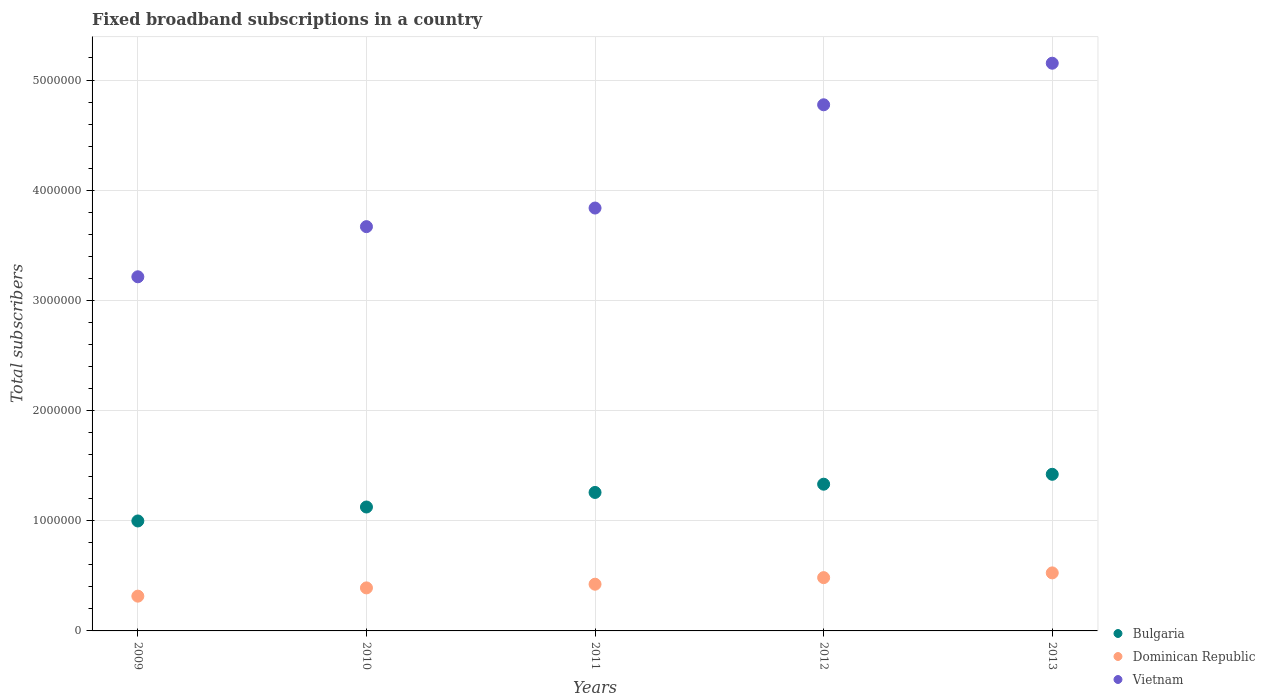How many different coloured dotlines are there?
Your answer should be very brief. 3. Is the number of dotlines equal to the number of legend labels?
Your answer should be very brief. Yes. What is the number of broadband subscriptions in Dominican Republic in 2010?
Offer a terse response. 3.91e+05. Across all years, what is the maximum number of broadband subscriptions in Bulgaria?
Your answer should be very brief. 1.42e+06. Across all years, what is the minimum number of broadband subscriptions in Vietnam?
Your answer should be compact. 3.21e+06. What is the total number of broadband subscriptions in Vietnam in the graph?
Provide a succinct answer. 2.06e+07. What is the difference between the number of broadband subscriptions in Bulgaria in 2009 and that in 2010?
Ensure brevity in your answer.  -1.27e+05. What is the difference between the number of broadband subscriptions in Bulgaria in 2011 and the number of broadband subscriptions in Vietnam in 2009?
Give a very brief answer. -1.96e+06. What is the average number of broadband subscriptions in Vietnam per year?
Provide a succinct answer. 4.13e+06. In the year 2010, what is the difference between the number of broadband subscriptions in Dominican Republic and number of broadband subscriptions in Bulgaria?
Offer a terse response. -7.34e+05. What is the ratio of the number of broadband subscriptions in Bulgaria in 2011 to that in 2013?
Offer a terse response. 0.88. Is the number of broadband subscriptions in Dominican Republic in 2010 less than that in 2011?
Give a very brief answer. Yes. Is the difference between the number of broadband subscriptions in Dominican Republic in 2011 and 2012 greater than the difference between the number of broadband subscriptions in Bulgaria in 2011 and 2012?
Provide a short and direct response. Yes. What is the difference between the highest and the second highest number of broadband subscriptions in Bulgaria?
Offer a terse response. 8.98e+04. What is the difference between the highest and the lowest number of broadband subscriptions in Vietnam?
Offer a very short reply. 1.94e+06. Is the sum of the number of broadband subscriptions in Dominican Republic in 2009 and 2012 greater than the maximum number of broadband subscriptions in Vietnam across all years?
Provide a succinct answer. No. Is it the case that in every year, the sum of the number of broadband subscriptions in Dominican Republic and number of broadband subscriptions in Bulgaria  is greater than the number of broadband subscriptions in Vietnam?
Your answer should be very brief. No. Is the number of broadband subscriptions in Vietnam strictly less than the number of broadband subscriptions in Dominican Republic over the years?
Offer a very short reply. No. How many dotlines are there?
Ensure brevity in your answer.  3. How many years are there in the graph?
Keep it short and to the point. 5. Does the graph contain grids?
Provide a succinct answer. Yes. Where does the legend appear in the graph?
Offer a terse response. Bottom right. How many legend labels are there?
Provide a succinct answer. 3. What is the title of the graph?
Provide a succinct answer. Fixed broadband subscriptions in a country. Does "Comoros" appear as one of the legend labels in the graph?
Provide a short and direct response. No. What is the label or title of the Y-axis?
Your response must be concise. Total subscribers. What is the Total subscribers in Bulgaria in 2009?
Your answer should be very brief. 9.98e+05. What is the Total subscribers in Dominican Republic in 2009?
Your answer should be compact. 3.16e+05. What is the Total subscribers of Vietnam in 2009?
Keep it short and to the point. 3.21e+06. What is the Total subscribers of Bulgaria in 2010?
Make the answer very short. 1.12e+06. What is the Total subscribers in Dominican Republic in 2010?
Provide a short and direct response. 3.91e+05. What is the Total subscribers in Vietnam in 2010?
Provide a short and direct response. 3.67e+06. What is the Total subscribers in Bulgaria in 2011?
Make the answer very short. 1.26e+06. What is the Total subscribers of Dominican Republic in 2011?
Your answer should be compact. 4.24e+05. What is the Total subscribers of Vietnam in 2011?
Offer a very short reply. 3.84e+06. What is the Total subscribers in Bulgaria in 2012?
Provide a short and direct response. 1.33e+06. What is the Total subscribers of Dominican Republic in 2012?
Give a very brief answer. 4.84e+05. What is the Total subscribers in Vietnam in 2012?
Give a very brief answer. 4.78e+06. What is the Total subscribers of Bulgaria in 2013?
Provide a succinct answer. 1.42e+06. What is the Total subscribers in Dominican Republic in 2013?
Provide a short and direct response. 5.27e+05. What is the Total subscribers of Vietnam in 2013?
Your answer should be compact. 5.15e+06. Across all years, what is the maximum Total subscribers of Bulgaria?
Ensure brevity in your answer.  1.42e+06. Across all years, what is the maximum Total subscribers of Dominican Republic?
Give a very brief answer. 5.27e+05. Across all years, what is the maximum Total subscribers of Vietnam?
Provide a succinct answer. 5.15e+06. Across all years, what is the minimum Total subscribers in Bulgaria?
Offer a very short reply. 9.98e+05. Across all years, what is the minimum Total subscribers of Dominican Republic?
Your response must be concise. 3.16e+05. Across all years, what is the minimum Total subscribers of Vietnam?
Offer a very short reply. 3.21e+06. What is the total Total subscribers in Bulgaria in the graph?
Offer a terse response. 6.13e+06. What is the total Total subscribers of Dominican Republic in the graph?
Give a very brief answer. 2.14e+06. What is the total Total subscribers of Vietnam in the graph?
Make the answer very short. 2.06e+07. What is the difference between the Total subscribers in Bulgaria in 2009 and that in 2010?
Provide a short and direct response. -1.27e+05. What is the difference between the Total subscribers of Dominican Republic in 2009 and that in 2010?
Your answer should be very brief. -7.49e+04. What is the difference between the Total subscribers of Vietnam in 2009 and that in 2010?
Offer a very short reply. -4.55e+05. What is the difference between the Total subscribers of Bulgaria in 2009 and that in 2011?
Your answer should be compact. -2.59e+05. What is the difference between the Total subscribers of Dominican Republic in 2009 and that in 2011?
Your answer should be very brief. -1.08e+05. What is the difference between the Total subscribers of Vietnam in 2009 and that in 2011?
Offer a terse response. -6.24e+05. What is the difference between the Total subscribers of Bulgaria in 2009 and that in 2012?
Your response must be concise. -3.34e+05. What is the difference between the Total subscribers of Dominican Republic in 2009 and that in 2012?
Keep it short and to the point. -1.68e+05. What is the difference between the Total subscribers in Vietnam in 2009 and that in 2012?
Provide a succinct answer. -1.56e+06. What is the difference between the Total subscribers in Bulgaria in 2009 and that in 2013?
Provide a short and direct response. -4.24e+05. What is the difference between the Total subscribers of Dominican Republic in 2009 and that in 2013?
Your answer should be very brief. -2.11e+05. What is the difference between the Total subscribers of Vietnam in 2009 and that in 2013?
Your response must be concise. -1.94e+06. What is the difference between the Total subscribers of Bulgaria in 2010 and that in 2011?
Keep it short and to the point. -1.32e+05. What is the difference between the Total subscribers of Dominican Republic in 2010 and that in 2011?
Your answer should be compact. -3.34e+04. What is the difference between the Total subscribers of Vietnam in 2010 and that in 2011?
Your answer should be compact. -1.69e+05. What is the difference between the Total subscribers in Bulgaria in 2010 and that in 2012?
Ensure brevity in your answer.  -2.07e+05. What is the difference between the Total subscribers of Dominican Republic in 2010 and that in 2012?
Your response must be concise. -9.31e+04. What is the difference between the Total subscribers in Vietnam in 2010 and that in 2012?
Keep it short and to the point. -1.11e+06. What is the difference between the Total subscribers in Bulgaria in 2010 and that in 2013?
Your answer should be very brief. -2.97e+05. What is the difference between the Total subscribers in Dominican Republic in 2010 and that in 2013?
Give a very brief answer. -1.36e+05. What is the difference between the Total subscribers of Vietnam in 2010 and that in 2013?
Provide a short and direct response. -1.48e+06. What is the difference between the Total subscribers in Bulgaria in 2011 and that in 2012?
Offer a very short reply. -7.50e+04. What is the difference between the Total subscribers of Dominican Republic in 2011 and that in 2012?
Ensure brevity in your answer.  -5.97e+04. What is the difference between the Total subscribers in Vietnam in 2011 and that in 2012?
Make the answer very short. -9.37e+05. What is the difference between the Total subscribers in Bulgaria in 2011 and that in 2013?
Your answer should be very brief. -1.65e+05. What is the difference between the Total subscribers in Dominican Republic in 2011 and that in 2013?
Your answer should be very brief. -1.03e+05. What is the difference between the Total subscribers of Vietnam in 2011 and that in 2013?
Your answer should be very brief. -1.31e+06. What is the difference between the Total subscribers of Bulgaria in 2012 and that in 2013?
Provide a succinct answer. -8.98e+04. What is the difference between the Total subscribers of Dominican Republic in 2012 and that in 2013?
Keep it short and to the point. -4.31e+04. What is the difference between the Total subscribers of Vietnam in 2012 and that in 2013?
Your answer should be very brief. -3.77e+05. What is the difference between the Total subscribers in Bulgaria in 2009 and the Total subscribers in Dominican Republic in 2010?
Offer a very short reply. 6.08e+05. What is the difference between the Total subscribers of Bulgaria in 2009 and the Total subscribers of Vietnam in 2010?
Ensure brevity in your answer.  -2.67e+06. What is the difference between the Total subscribers in Dominican Republic in 2009 and the Total subscribers in Vietnam in 2010?
Keep it short and to the point. -3.35e+06. What is the difference between the Total subscribers in Bulgaria in 2009 and the Total subscribers in Dominican Republic in 2011?
Keep it short and to the point. 5.74e+05. What is the difference between the Total subscribers of Bulgaria in 2009 and the Total subscribers of Vietnam in 2011?
Keep it short and to the point. -2.84e+06. What is the difference between the Total subscribers of Dominican Republic in 2009 and the Total subscribers of Vietnam in 2011?
Provide a short and direct response. -3.52e+06. What is the difference between the Total subscribers in Bulgaria in 2009 and the Total subscribers in Dominican Republic in 2012?
Offer a terse response. 5.14e+05. What is the difference between the Total subscribers in Bulgaria in 2009 and the Total subscribers in Vietnam in 2012?
Your answer should be very brief. -3.78e+06. What is the difference between the Total subscribers of Dominican Republic in 2009 and the Total subscribers of Vietnam in 2012?
Ensure brevity in your answer.  -4.46e+06. What is the difference between the Total subscribers of Bulgaria in 2009 and the Total subscribers of Dominican Republic in 2013?
Ensure brevity in your answer.  4.71e+05. What is the difference between the Total subscribers of Bulgaria in 2009 and the Total subscribers of Vietnam in 2013?
Offer a very short reply. -4.15e+06. What is the difference between the Total subscribers in Dominican Republic in 2009 and the Total subscribers in Vietnam in 2013?
Make the answer very short. -4.84e+06. What is the difference between the Total subscribers of Bulgaria in 2010 and the Total subscribers of Dominican Republic in 2011?
Offer a very short reply. 7.01e+05. What is the difference between the Total subscribers of Bulgaria in 2010 and the Total subscribers of Vietnam in 2011?
Offer a terse response. -2.71e+06. What is the difference between the Total subscribers in Dominican Republic in 2010 and the Total subscribers in Vietnam in 2011?
Keep it short and to the point. -3.45e+06. What is the difference between the Total subscribers of Bulgaria in 2010 and the Total subscribers of Dominican Republic in 2012?
Your answer should be compact. 6.41e+05. What is the difference between the Total subscribers in Bulgaria in 2010 and the Total subscribers in Vietnam in 2012?
Ensure brevity in your answer.  -3.65e+06. What is the difference between the Total subscribers of Dominican Republic in 2010 and the Total subscribers of Vietnam in 2012?
Your answer should be very brief. -4.38e+06. What is the difference between the Total subscribers of Bulgaria in 2010 and the Total subscribers of Dominican Republic in 2013?
Offer a terse response. 5.98e+05. What is the difference between the Total subscribers in Bulgaria in 2010 and the Total subscribers in Vietnam in 2013?
Give a very brief answer. -4.03e+06. What is the difference between the Total subscribers of Dominican Republic in 2010 and the Total subscribers of Vietnam in 2013?
Give a very brief answer. -4.76e+06. What is the difference between the Total subscribers in Bulgaria in 2011 and the Total subscribers in Dominican Republic in 2012?
Your answer should be very brief. 7.73e+05. What is the difference between the Total subscribers in Bulgaria in 2011 and the Total subscribers in Vietnam in 2012?
Provide a succinct answer. -3.52e+06. What is the difference between the Total subscribers of Dominican Republic in 2011 and the Total subscribers of Vietnam in 2012?
Offer a terse response. -4.35e+06. What is the difference between the Total subscribers in Bulgaria in 2011 and the Total subscribers in Dominican Republic in 2013?
Provide a short and direct response. 7.30e+05. What is the difference between the Total subscribers in Bulgaria in 2011 and the Total subscribers in Vietnam in 2013?
Provide a short and direct response. -3.90e+06. What is the difference between the Total subscribers in Dominican Republic in 2011 and the Total subscribers in Vietnam in 2013?
Ensure brevity in your answer.  -4.73e+06. What is the difference between the Total subscribers in Bulgaria in 2012 and the Total subscribers in Dominican Republic in 2013?
Give a very brief answer. 8.05e+05. What is the difference between the Total subscribers of Bulgaria in 2012 and the Total subscribers of Vietnam in 2013?
Offer a terse response. -3.82e+06. What is the difference between the Total subscribers in Dominican Republic in 2012 and the Total subscribers in Vietnam in 2013?
Offer a terse response. -4.67e+06. What is the average Total subscribers in Bulgaria per year?
Your answer should be compact. 1.23e+06. What is the average Total subscribers of Dominican Republic per year?
Provide a short and direct response. 4.28e+05. What is the average Total subscribers in Vietnam per year?
Provide a succinct answer. 4.13e+06. In the year 2009, what is the difference between the Total subscribers of Bulgaria and Total subscribers of Dominican Republic?
Give a very brief answer. 6.82e+05. In the year 2009, what is the difference between the Total subscribers of Bulgaria and Total subscribers of Vietnam?
Provide a short and direct response. -2.22e+06. In the year 2009, what is the difference between the Total subscribers in Dominican Republic and Total subscribers in Vietnam?
Offer a very short reply. -2.90e+06. In the year 2010, what is the difference between the Total subscribers of Bulgaria and Total subscribers of Dominican Republic?
Make the answer very short. 7.34e+05. In the year 2010, what is the difference between the Total subscribers of Bulgaria and Total subscribers of Vietnam?
Provide a short and direct response. -2.54e+06. In the year 2010, what is the difference between the Total subscribers of Dominican Republic and Total subscribers of Vietnam?
Make the answer very short. -3.28e+06. In the year 2011, what is the difference between the Total subscribers in Bulgaria and Total subscribers in Dominican Republic?
Make the answer very short. 8.33e+05. In the year 2011, what is the difference between the Total subscribers in Bulgaria and Total subscribers in Vietnam?
Your answer should be very brief. -2.58e+06. In the year 2011, what is the difference between the Total subscribers of Dominican Republic and Total subscribers of Vietnam?
Provide a short and direct response. -3.41e+06. In the year 2012, what is the difference between the Total subscribers in Bulgaria and Total subscribers in Dominican Republic?
Offer a terse response. 8.48e+05. In the year 2012, what is the difference between the Total subscribers of Bulgaria and Total subscribers of Vietnam?
Give a very brief answer. -3.44e+06. In the year 2012, what is the difference between the Total subscribers of Dominican Republic and Total subscribers of Vietnam?
Ensure brevity in your answer.  -4.29e+06. In the year 2013, what is the difference between the Total subscribers of Bulgaria and Total subscribers of Dominican Republic?
Make the answer very short. 8.95e+05. In the year 2013, what is the difference between the Total subscribers in Bulgaria and Total subscribers in Vietnam?
Provide a short and direct response. -3.73e+06. In the year 2013, what is the difference between the Total subscribers of Dominican Republic and Total subscribers of Vietnam?
Provide a short and direct response. -4.63e+06. What is the ratio of the Total subscribers in Bulgaria in 2009 to that in 2010?
Make the answer very short. 0.89. What is the ratio of the Total subscribers of Dominican Republic in 2009 to that in 2010?
Your response must be concise. 0.81. What is the ratio of the Total subscribers of Vietnam in 2009 to that in 2010?
Offer a terse response. 0.88. What is the ratio of the Total subscribers of Bulgaria in 2009 to that in 2011?
Provide a short and direct response. 0.79. What is the ratio of the Total subscribers of Dominican Republic in 2009 to that in 2011?
Keep it short and to the point. 0.74. What is the ratio of the Total subscribers in Vietnam in 2009 to that in 2011?
Keep it short and to the point. 0.84. What is the ratio of the Total subscribers in Bulgaria in 2009 to that in 2012?
Keep it short and to the point. 0.75. What is the ratio of the Total subscribers in Dominican Republic in 2009 to that in 2012?
Your answer should be compact. 0.65. What is the ratio of the Total subscribers of Vietnam in 2009 to that in 2012?
Your answer should be very brief. 0.67. What is the ratio of the Total subscribers of Bulgaria in 2009 to that in 2013?
Provide a succinct answer. 0.7. What is the ratio of the Total subscribers of Dominican Republic in 2009 to that in 2013?
Provide a short and direct response. 0.6. What is the ratio of the Total subscribers in Vietnam in 2009 to that in 2013?
Your answer should be very brief. 0.62. What is the ratio of the Total subscribers of Bulgaria in 2010 to that in 2011?
Your answer should be compact. 0.89. What is the ratio of the Total subscribers of Dominican Republic in 2010 to that in 2011?
Your answer should be very brief. 0.92. What is the ratio of the Total subscribers of Vietnam in 2010 to that in 2011?
Provide a short and direct response. 0.96. What is the ratio of the Total subscribers of Bulgaria in 2010 to that in 2012?
Your answer should be very brief. 0.84. What is the ratio of the Total subscribers in Dominican Republic in 2010 to that in 2012?
Ensure brevity in your answer.  0.81. What is the ratio of the Total subscribers of Vietnam in 2010 to that in 2012?
Provide a short and direct response. 0.77. What is the ratio of the Total subscribers of Bulgaria in 2010 to that in 2013?
Make the answer very short. 0.79. What is the ratio of the Total subscribers in Dominican Republic in 2010 to that in 2013?
Provide a short and direct response. 0.74. What is the ratio of the Total subscribers of Vietnam in 2010 to that in 2013?
Offer a very short reply. 0.71. What is the ratio of the Total subscribers in Bulgaria in 2011 to that in 2012?
Your answer should be compact. 0.94. What is the ratio of the Total subscribers of Dominican Republic in 2011 to that in 2012?
Offer a very short reply. 0.88. What is the ratio of the Total subscribers in Vietnam in 2011 to that in 2012?
Make the answer very short. 0.8. What is the ratio of the Total subscribers in Bulgaria in 2011 to that in 2013?
Make the answer very short. 0.88. What is the ratio of the Total subscribers of Dominican Republic in 2011 to that in 2013?
Offer a terse response. 0.8. What is the ratio of the Total subscribers of Vietnam in 2011 to that in 2013?
Make the answer very short. 0.74. What is the ratio of the Total subscribers in Bulgaria in 2012 to that in 2013?
Offer a very short reply. 0.94. What is the ratio of the Total subscribers in Dominican Republic in 2012 to that in 2013?
Offer a terse response. 0.92. What is the ratio of the Total subscribers in Vietnam in 2012 to that in 2013?
Your answer should be very brief. 0.93. What is the difference between the highest and the second highest Total subscribers of Bulgaria?
Provide a succinct answer. 8.98e+04. What is the difference between the highest and the second highest Total subscribers in Dominican Republic?
Make the answer very short. 4.31e+04. What is the difference between the highest and the second highest Total subscribers in Vietnam?
Make the answer very short. 3.77e+05. What is the difference between the highest and the lowest Total subscribers of Bulgaria?
Make the answer very short. 4.24e+05. What is the difference between the highest and the lowest Total subscribers of Dominican Republic?
Your answer should be compact. 2.11e+05. What is the difference between the highest and the lowest Total subscribers of Vietnam?
Keep it short and to the point. 1.94e+06. 